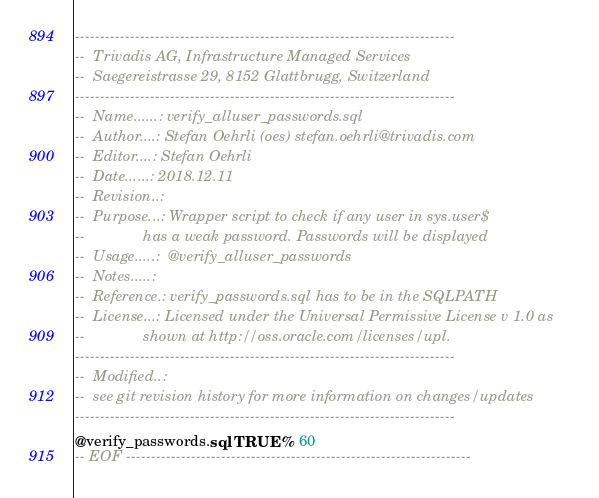<code> <loc_0><loc_0><loc_500><loc_500><_SQL_>----------------------------------------------------------------------------
--  Trivadis AG, Infrastructure Managed Services
--  Saegereistrasse 29, 8152 Glattbrugg, Switzerland
----------------------------------------------------------------------------
--  Name......: verify_alluser_passwords.sql
--  Author....: Stefan Oehrli (oes) stefan.oehrli@trivadis.com
--  Editor....: Stefan Oehrli
--  Date......: 2018.12.11
--  Revision..:  
--  Purpose...: Wrapper script to check if any user in sys.user$  
--              has a weak password. Passwords will be displayed
--  Usage.....:  @verify_alluser_passwords
--  Notes.....: 
--  Reference.: verify_passwords.sql has to be in the SQLPATH
--  License...: Licensed under the Universal Permissive License v 1.0 as 
--              shown at http://oss.oracle.com/licenses/upl.
----------------------------------------------------------------------------
--  Modified..:
--  see git revision history for more information on changes/updates
----------------------------------------------------------------------------
@verify_passwords.sql TRUE % 60
-- EOF ---------------------------------------------------------------------</code> 